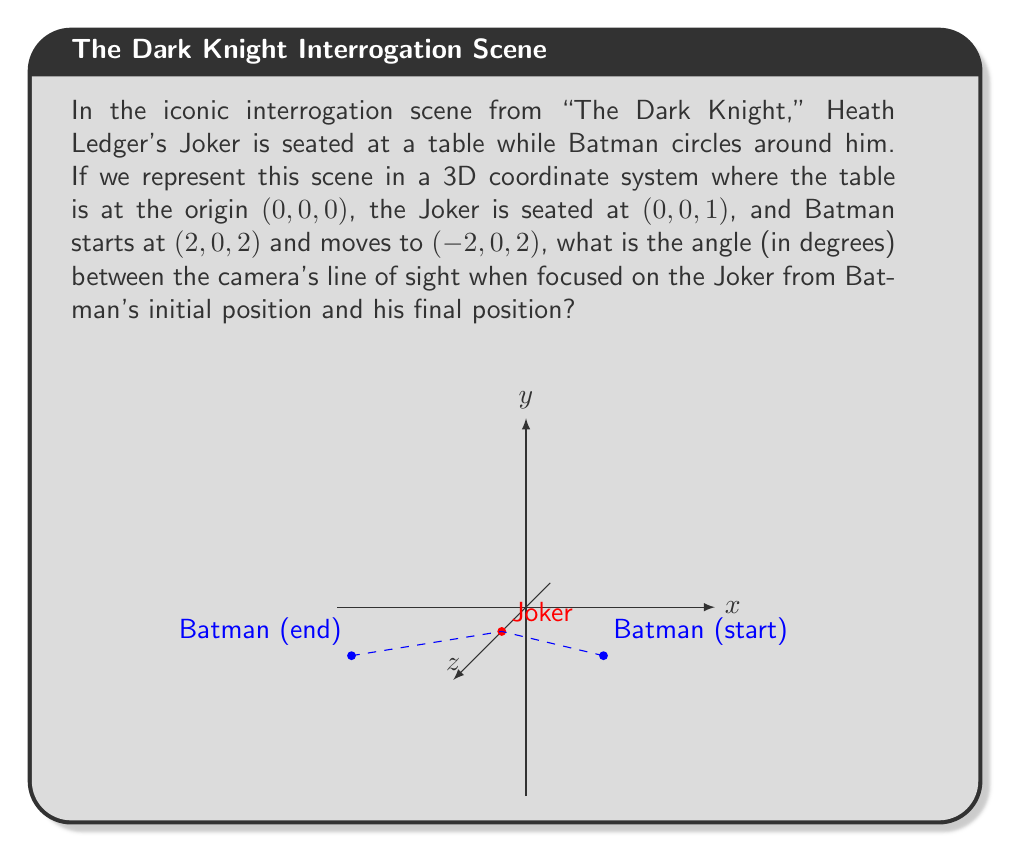Teach me how to tackle this problem. To solve this problem, we'll follow these steps:

1) First, let's identify the vectors from Batman's positions to the Joker:

   Initial vector: $\vec{v_1} = (0,0,1) - (2,0,2) = (-2,0,-1)$
   Final vector: $\vec{v_2} = (0,0,1) - (-2,0,2) = (2,0,-1)$

2) The angle between these vectors can be found using the dot product formula:

   $\cos \theta = \frac{\vec{v_1} \cdot \vec{v_2}}{|\vec{v_1}||\vec{v_2}|}$

3) Let's calculate the dot product $\vec{v_1} \cdot \vec{v_2}$:

   $\vec{v_1} \cdot \vec{v_2} = (-2)(2) + (0)(0) + (-1)(-1) = -4 + 0 + 1 = -3$

4) Now, let's calculate the magnitudes of the vectors:

   $|\vec{v_1}| = \sqrt{(-2)^2 + 0^2 + (-1)^2} = \sqrt{5}$
   $|\vec{v_2}| = \sqrt{2^2 + 0^2 + (-1)^2} = \sqrt{5}$

5) Substituting into the formula:

   $\cos \theta = \frac{-3}{(\sqrt{5})(\sqrt{5})} = \frac{-3}{5}$

6) To find $\theta$, we take the inverse cosine (arccos) of both sides:

   $\theta = \arccos(\frac{-3}{5})$

7) Converting to degrees:

   $\theta = \arccos(\frac{-3}{5}) \cdot \frac{180}{\pi} \approx 126.87°$
Answer: $126.87°$ 